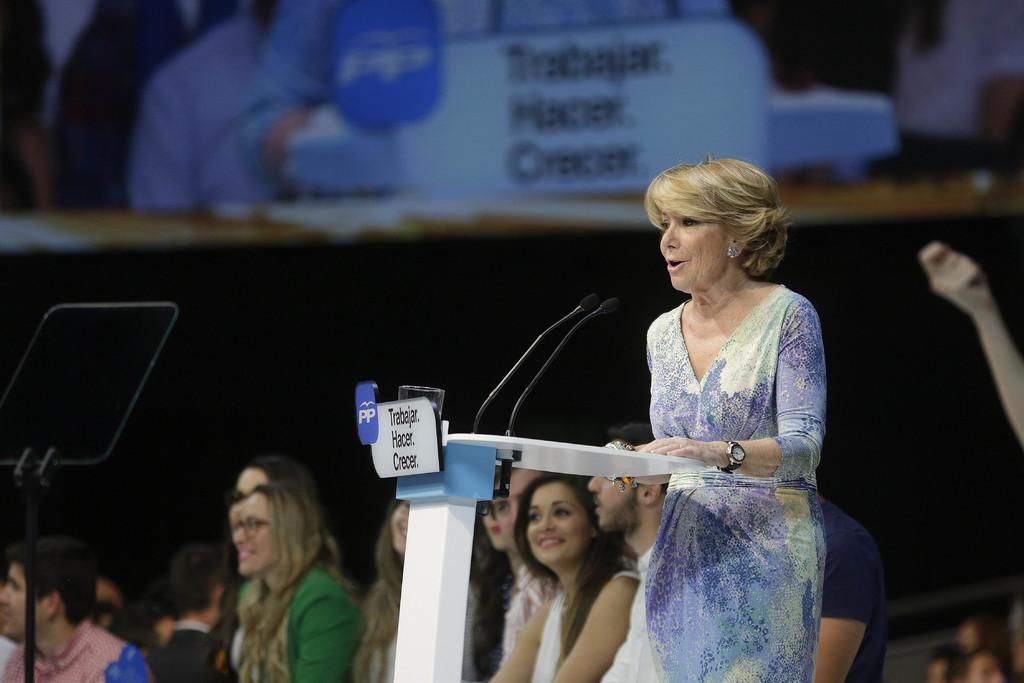What are the people in the image doing? The people in the image are sitting on chairs. What is the woman near the podium doing? The woman is standing near a podium in the image. What can be seen in the background of the image? There is a screen visible in the background of the image. What type of heart surgery is being performed by the woman standing near the podium in the image? There is no heart surgery or any medical procedure being performed in the image. The woman is simply standing near a podium. 